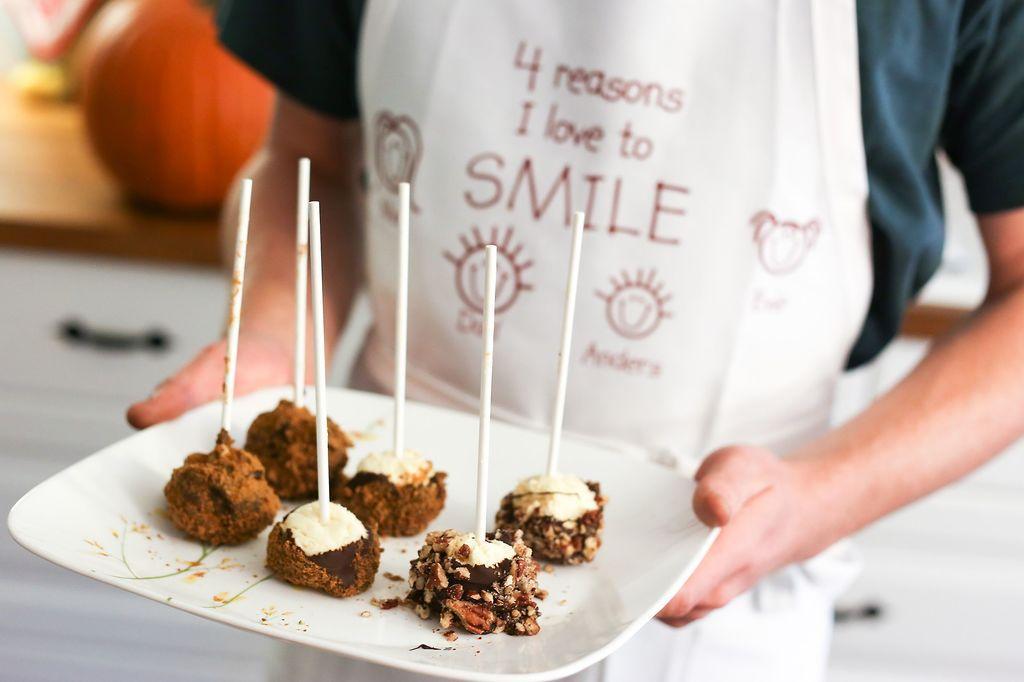Could you give a brief overview of what you see in this image? The man in blue T-shirt who is wearing a white apron is holding a white plate. This plate contains six chocolates. Behind him, we see a table on which pumpkin is placed. It is blurred in the background. 